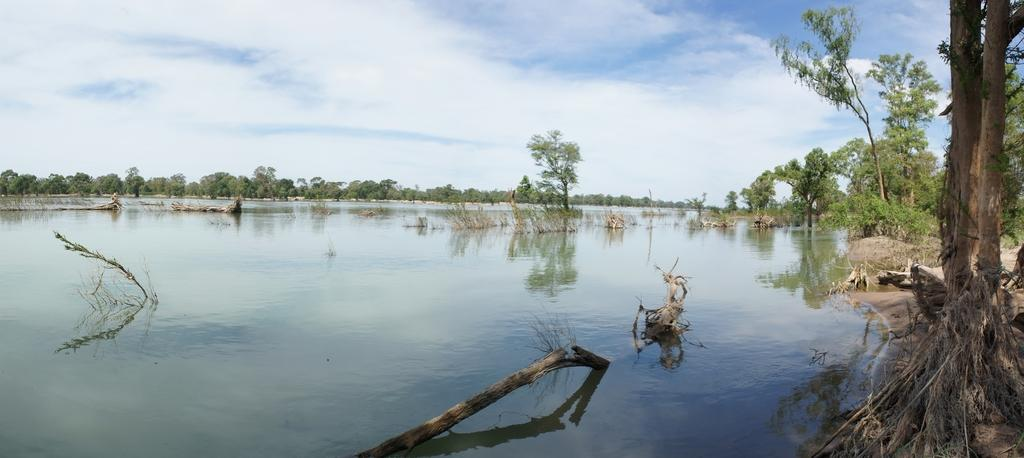What is at the bottom of the image? There is water at the bottom of the image. What can be seen in the water? There are sticks and plants in the water. What is visible in the background of the image? There are trees in the background of the image. What is visible at the top of the image? The sky is visible at the top of the image. What can be seen in the sky? There are clouds in the sky. Can you see any fairies dancing on the toes of the plants in the image? There are no fairies or toes of plants present in the image; it features water, sticks, plants, trees, and clouds in the sky. 